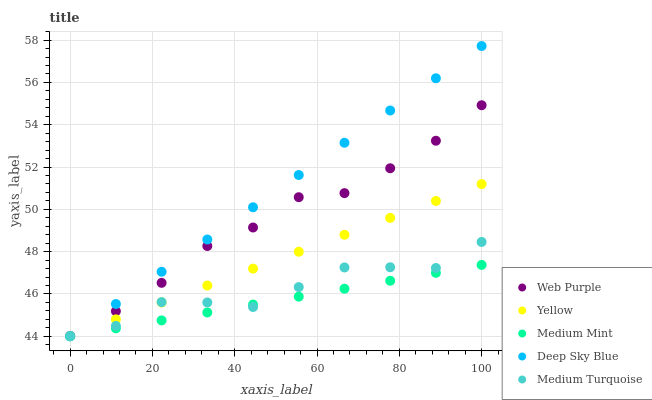Does Medium Mint have the minimum area under the curve?
Answer yes or no. Yes. Does Deep Sky Blue have the maximum area under the curve?
Answer yes or no. Yes. Does Web Purple have the minimum area under the curve?
Answer yes or no. No. Does Web Purple have the maximum area under the curve?
Answer yes or no. No. Is Medium Mint the smoothest?
Answer yes or no. Yes. Is Medium Turquoise the roughest?
Answer yes or no. Yes. Is Web Purple the smoothest?
Answer yes or no. No. Is Web Purple the roughest?
Answer yes or no. No. Does Medium Mint have the lowest value?
Answer yes or no. Yes. Does Web Purple have the lowest value?
Answer yes or no. No. Does Deep Sky Blue have the highest value?
Answer yes or no. Yes. Does Web Purple have the highest value?
Answer yes or no. No. Is Yellow less than Web Purple?
Answer yes or no. Yes. Is Web Purple greater than Medium Turquoise?
Answer yes or no. Yes. Does Yellow intersect Medium Turquoise?
Answer yes or no. Yes. Is Yellow less than Medium Turquoise?
Answer yes or no. No. Is Yellow greater than Medium Turquoise?
Answer yes or no. No. Does Yellow intersect Web Purple?
Answer yes or no. No. 